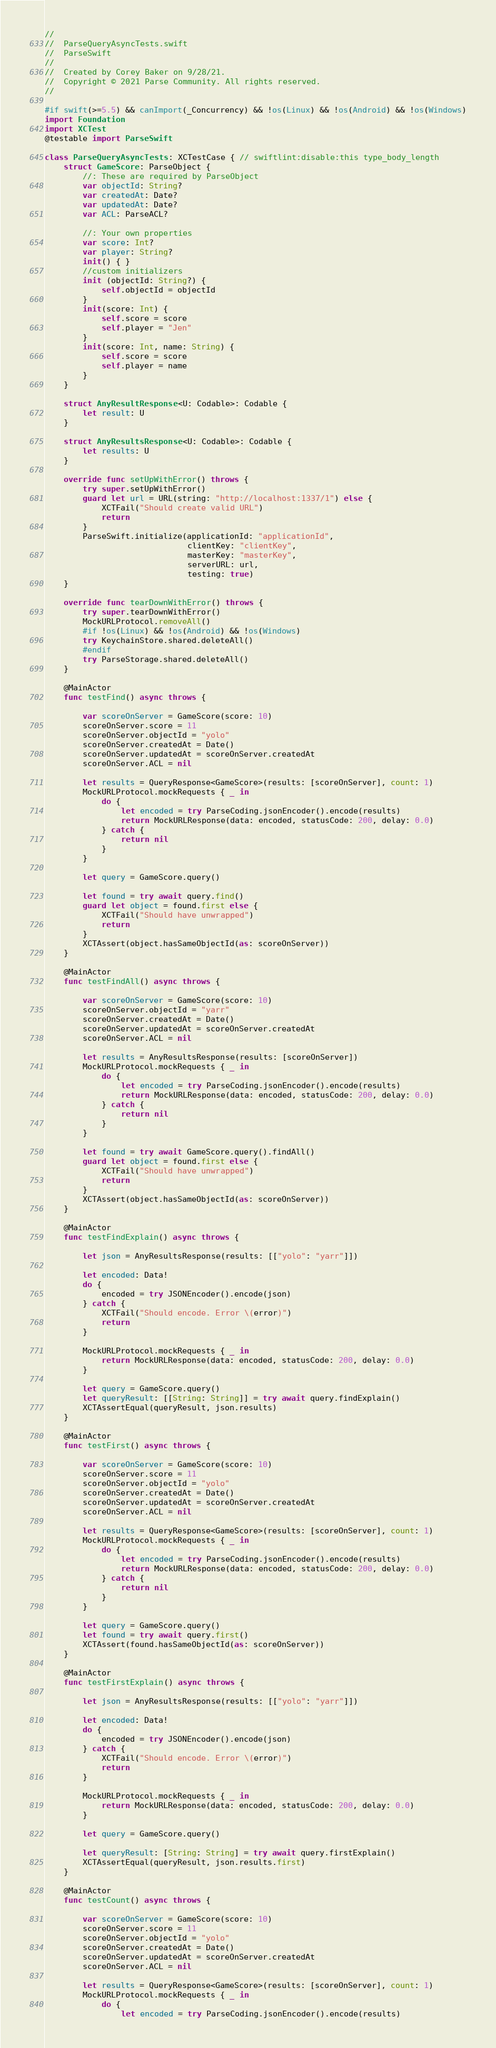<code> <loc_0><loc_0><loc_500><loc_500><_Swift_>//
//  ParseQueryAsyncTests.swift
//  ParseSwift
//
//  Created by Corey Baker on 9/28/21.
//  Copyright © 2021 Parse Community. All rights reserved.
//

#if swift(>=5.5) && canImport(_Concurrency) && !os(Linux) && !os(Android) && !os(Windows)
import Foundation
import XCTest
@testable import ParseSwift

class ParseQueryAsyncTests: XCTestCase { // swiftlint:disable:this type_body_length
    struct GameScore: ParseObject {
        //: These are required by ParseObject
        var objectId: String?
        var createdAt: Date?
        var updatedAt: Date?
        var ACL: ParseACL?

        //: Your own properties
        var score: Int?
        var player: String?
        init() { }
        //custom initializers
        init (objectId: String?) {
            self.objectId = objectId
        }
        init(score: Int) {
            self.score = score
            self.player = "Jen"
        }
        init(score: Int, name: String) {
            self.score = score
            self.player = name
        }
    }

    struct AnyResultResponse<U: Codable>: Codable {
        let result: U
    }

    struct AnyResultsResponse<U: Codable>: Codable {
        let results: U
    }

    override func setUpWithError() throws {
        try super.setUpWithError()
        guard let url = URL(string: "http://localhost:1337/1") else {
            XCTFail("Should create valid URL")
            return
        }
        ParseSwift.initialize(applicationId: "applicationId",
                              clientKey: "clientKey",
                              masterKey: "masterKey",
                              serverURL: url,
                              testing: true)
    }

    override func tearDownWithError() throws {
        try super.tearDownWithError()
        MockURLProtocol.removeAll()
        #if !os(Linux) && !os(Android) && !os(Windows)
        try KeychainStore.shared.deleteAll()
        #endif
        try ParseStorage.shared.deleteAll()
    }

    @MainActor
    func testFind() async throws {

        var scoreOnServer = GameScore(score: 10)
        scoreOnServer.score = 11
        scoreOnServer.objectId = "yolo"
        scoreOnServer.createdAt = Date()
        scoreOnServer.updatedAt = scoreOnServer.createdAt
        scoreOnServer.ACL = nil

        let results = QueryResponse<GameScore>(results: [scoreOnServer], count: 1)
        MockURLProtocol.mockRequests { _ in
            do {
                let encoded = try ParseCoding.jsonEncoder().encode(results)
                return MockURLResponse(data: encoded, statusCode: 200, delay: 0.0)
            } catch {
                return nil
            }
        }

        let query = GameScore.query()

        let found = try await query.find()
        guard let object = found.first else {
            XCTFail("Should have unwrapped")
            return
        }
        XCTAssert(object.hasSameObjectId(as: scoreOnServer))
    }

    @MainActor
    func testFindAll() async throws {

        var scoreOnServer = GameScore(score: 10)
        scoreOnServer.objectId = "yarr"
        scoreOnServer.createdAt = Date()
        scoreOnServer.updatedAt = scoreOnServer.createdAt
        scoreOnServer.ACL = nil

        let results = AnyResultsResponse(results: [scoreOnServer])
        MockURLProtocol.mockRequests { _ in
            do {
                let encoded = try ParseCoding.jsonEncoder().encode(results)
                return MockURLResponse(data: encoded, statusCode: 200, delay: 0.0)
            } catch {
                return nil
            }
        }

        let found = try await GameScore.query().findAll()
        guard let object = found.first else {
            XCTFail("Should have unwrapped")
            return
        }
        XCTAssert(object.hasSameObjectId(as: scoreOnServer))
    }

    @MainActor
    func testFindExplain() async throws {

        let json = AnyResultsResponse(results: [["yolo": "yarr"]])

        let encoded: Data!
        do {
            encoded = try JSONEncoder().encode(json)
        } catch {
            XCTFail("Should encode. Error \(error)")
            return
        }

        MockURLProtocol.mockRequests { _ in
            return MockURLResponse(data: encoded, statusCode: 200, delay: 0.0)
        }

        let query = GameScore.query()
        let queryResult: [[String: String]] = try await query.findExplain()
        XCTAssertEqual(queryResult, json.results)
    }

    @MainActor
    func testFirst() async throws {

        var scoreOnServer = GameScore(score: 10)
        scoreOnServer.score = 11
        scoreOnServer.objectId = "yolo"
        scoreOnServer.createdAt = Date()
        scoreOnServer.updatedAt = scoreOnServer.createdAt
        scoreOnServer.ACL = nil

        let results = QueryResponse<GameScore>(results: [scoreOnServer], count: 1)
        MockURLProtocol.mockRequests { _ in
            do {
                let encoded = try ParseCoding.jsonEncoder().encode(results)
                return MockURLResponse(data: encoded, statusCode: 200, delay: 0.0)
            } catch {
                return nil
            }
        }

        let query = GameScore.query()
        let found = try await query.first()
        XCTAssert(found.hasSameObjectId(as: scoreOnServer))
    }

    @MainActor
    func testFirstExplain() async throws {

        let json = AnyResultsResponse(results: [["yolo": "yarr"]])

        let encoded: Data!
        do {
            encoded = try JSONEncoder().encode(json)
        } catch {
            XCTFail("Should encode. Error \(error)")
            return
        }

        MockURLProtocol.mockRequests { _ in
            return MockURLResponse(data: encoded, statusCode: 200, delay: 0.0)
        }

        let query = GameScore.query()

        let queryResult: [String: String] = try await query.firstExplain()
        XCTAssertEqual(queryResult, json.results.first)
    }

    @MainActor
    func testCount() async throws {

        var scoreOnServer = GameScore(score: 10)
        scoreOnServer.score = 11
        scoreOnServer.objectId = "yolo"
        scoreOnServer.createdAt = Date()
        scoreOnServer.updatedAt = scoreOnServer.createdAt
        scoreOnServer.ACL = nil

        let results = QueryResponse<GameScore>(results: [scoreOnServer], count: 1)
        MockURLProtocol.mockRequests { _ in
            do {
                let encoded = try ParseCoding.jsonEncoder().encode(results)</code> 